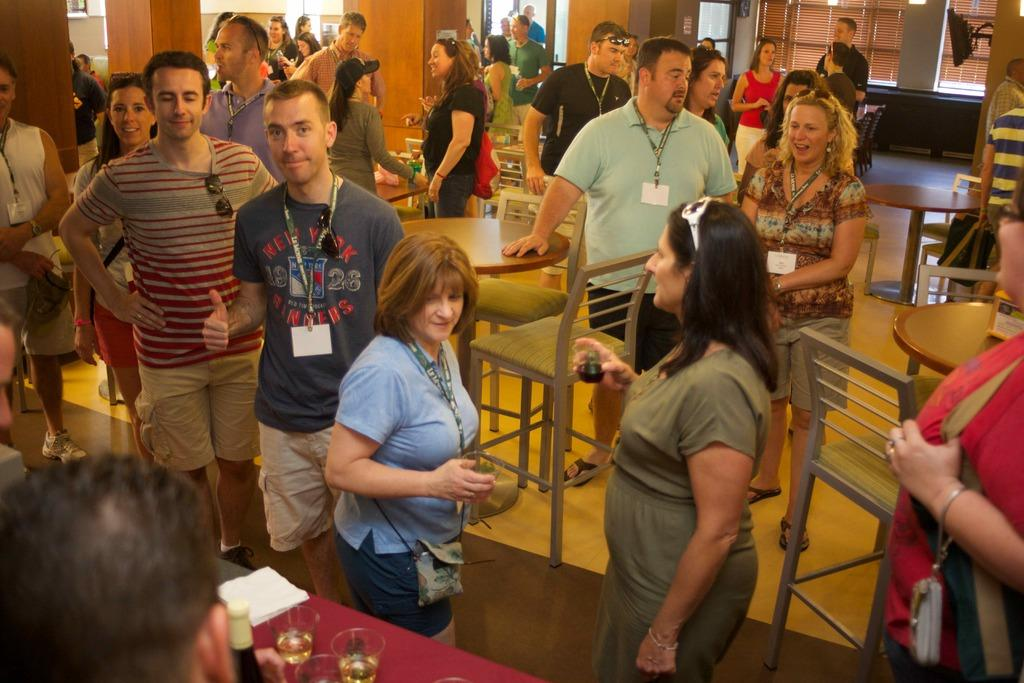What can be seen in the image involving a group of people? There is a group of people in the image. What objects are present on the table in the image? There are glasses and a bottle on the table in the image. What type of furniture is visible in the image? There are chairs in the image. What electronic device can be seen in the image? There is a monitor in the image. What accessory is present in the image that might be used for vision correction? There are spectacles in the image. How many feet are visible in the image? There is no mention of feet or any body parts in the image; it primarily features people, objects, and furniture. 